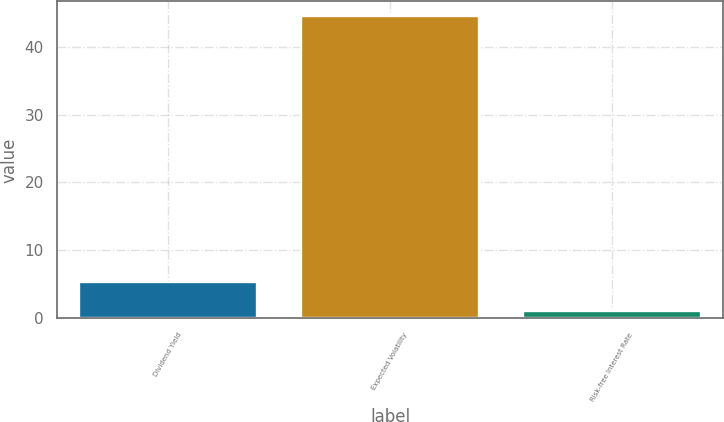Convert chart. <chart><loc_0><loc_0><loc_500><loc_500><bar_chart><fcel>Dividend Yield<fcel>Expected Volatility<fcel>Risk-free Interest Rate<nl><fcel>5.38<fcel>44.44<fcel>1.04<nl></chart> 